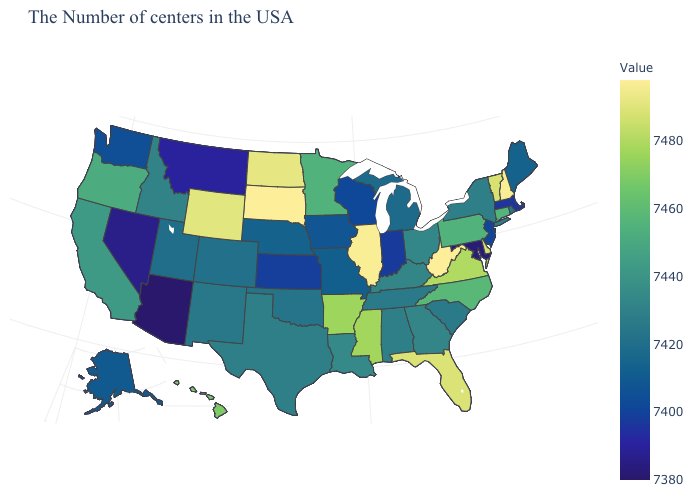Among the states that border Oregon , does Washington have the lowest value?
Keep it brief. No. Among the states that border Indiana , which have the lowest value?
Write a very short answer. Michigan. Among the states that border Ohio , which have the lowest value?
Be succinct. Indiana. Which states have the highest value in the USA?
Short answer required. West Virginia, South Dakota. Among the states that border Alabama , does Tennessee have the lowest value?
Be succinct. Yes. 